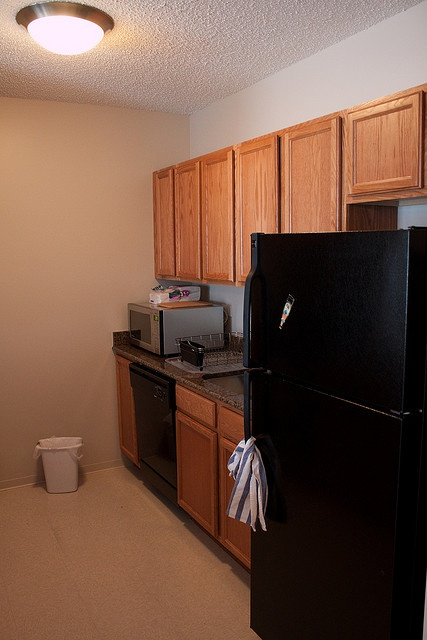Describe the objects in this image and their specific colors. I can see refrigerator in pink, black, darkgray, and gray tones, oven in pink, black, maroon, and gray tones, microwave in pink, gray, maroon, and black tones, and sink in black, pink, and maroon tones in this image. 